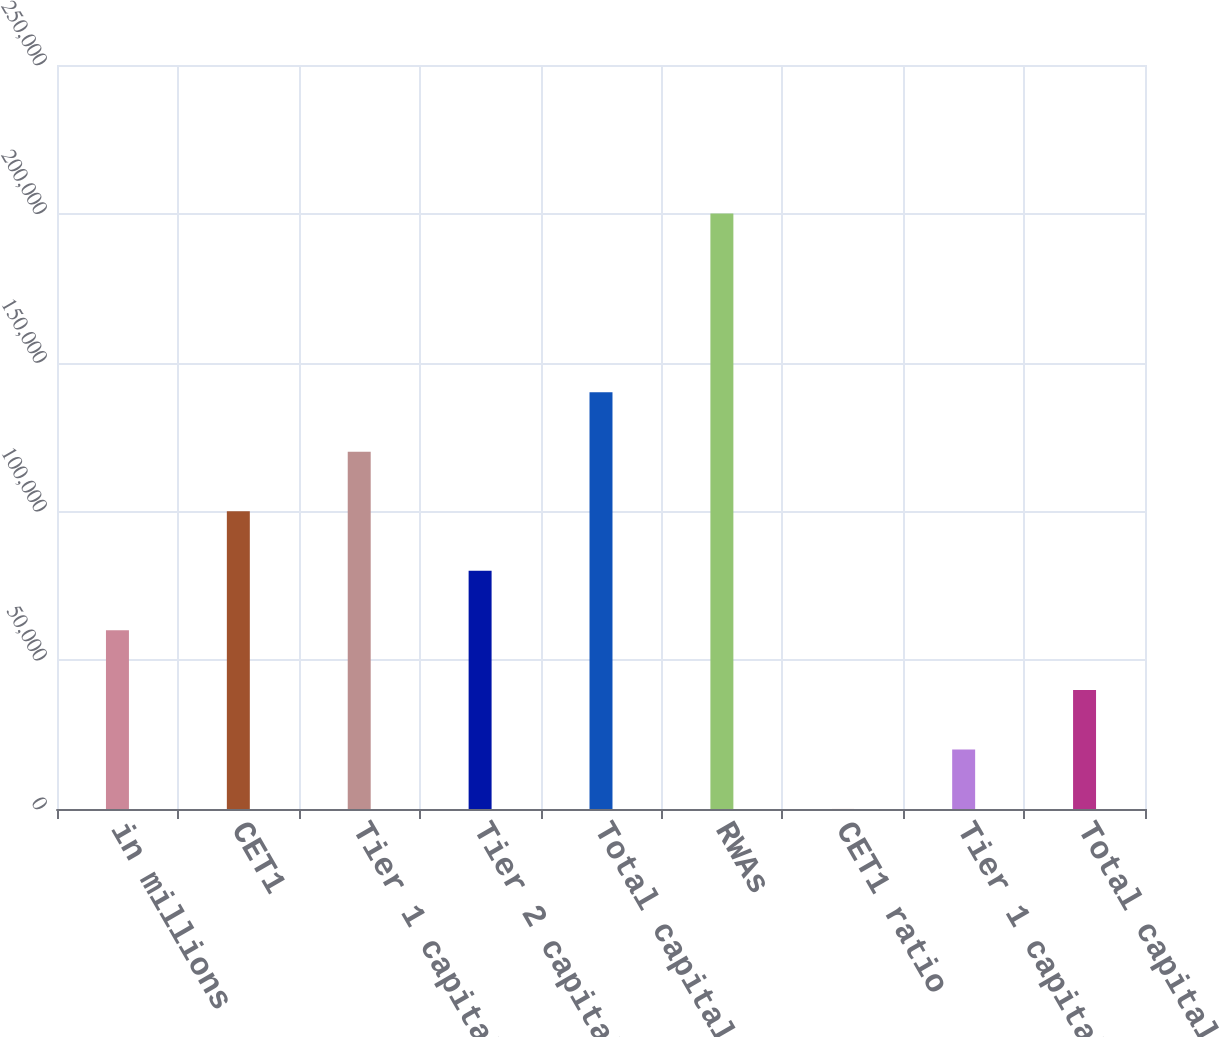<chart> <loc_0><loc_0><loc_500><loc_500><bar_chart><fcel>in millions<fcel>CET1<fcel>Tier 1 capital<fcel>Tier 2 capital<fcel>Total capital<fcel>RWAs<fcel>CET1 ratio<fcel>Tier 1 capital ratio<fcel>Total capital ratio<nl><fcel>60035.1<fcel>100050<fcel>120058<fcel>80042.8<fcel>140066<fcel>200089<fcel>12<fcel>20019.7<fcel>40027.4<nl></chart> 